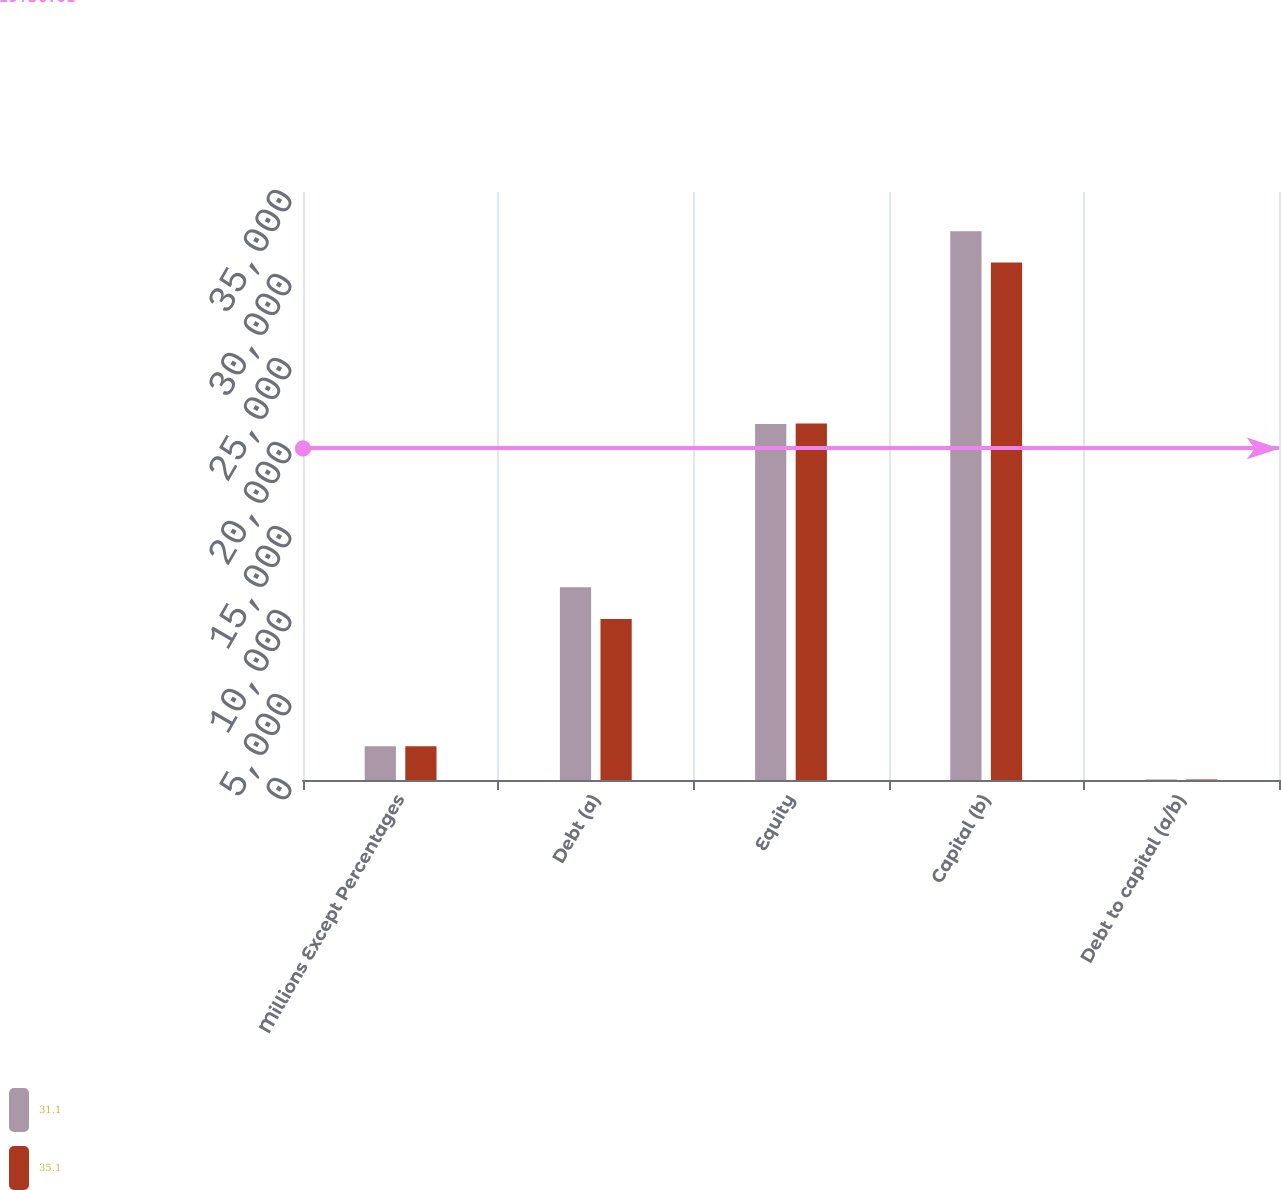<chart> <loc_0><loc_0><loc_500><loc_500><stacked_bar_chart><ecel><fcel>Millions Except Percentages<fcel>Debt (a)<fcel>Equity<fcel>Capital (b)<fcel>Debt to capital (a/b)<nl><fcel>31.1<fcel>2014<fcel>11480<fcel>21189<fcel>32669<fcel>35.1<nl><fcel>35.1<fcel>2013<fcel>9577<fcel>21225<fcel>30802<fcel>31.1<nl></chart> 